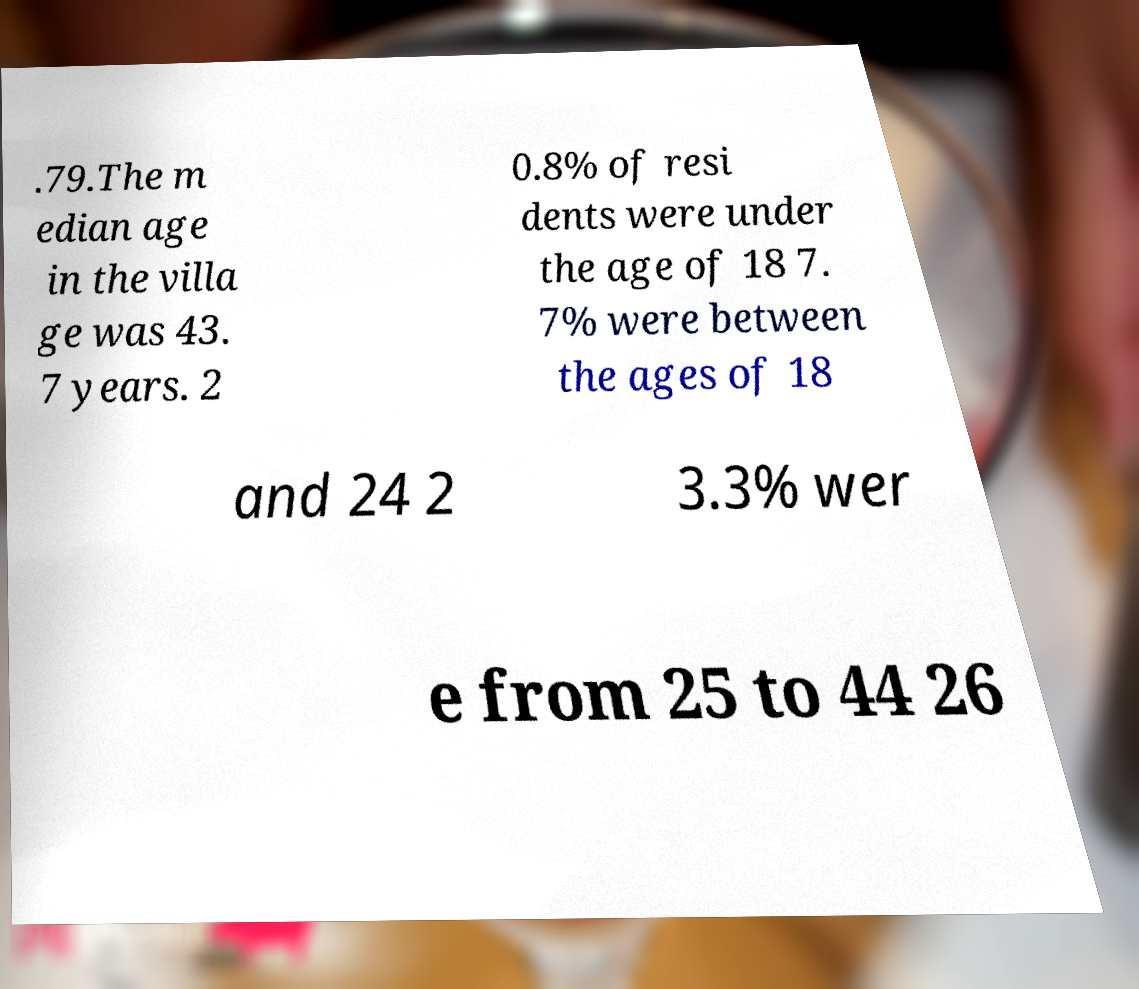What messages or text are displayed in this image? I need them in a readable, typed format. .79.The m edian age in the villa ge was 43. 7 years. 2 0.8% of resi dents were under the age of 18 7. 7% were between the ages of 18 and 24 2 3.3% wer e from 25 to 44 26 